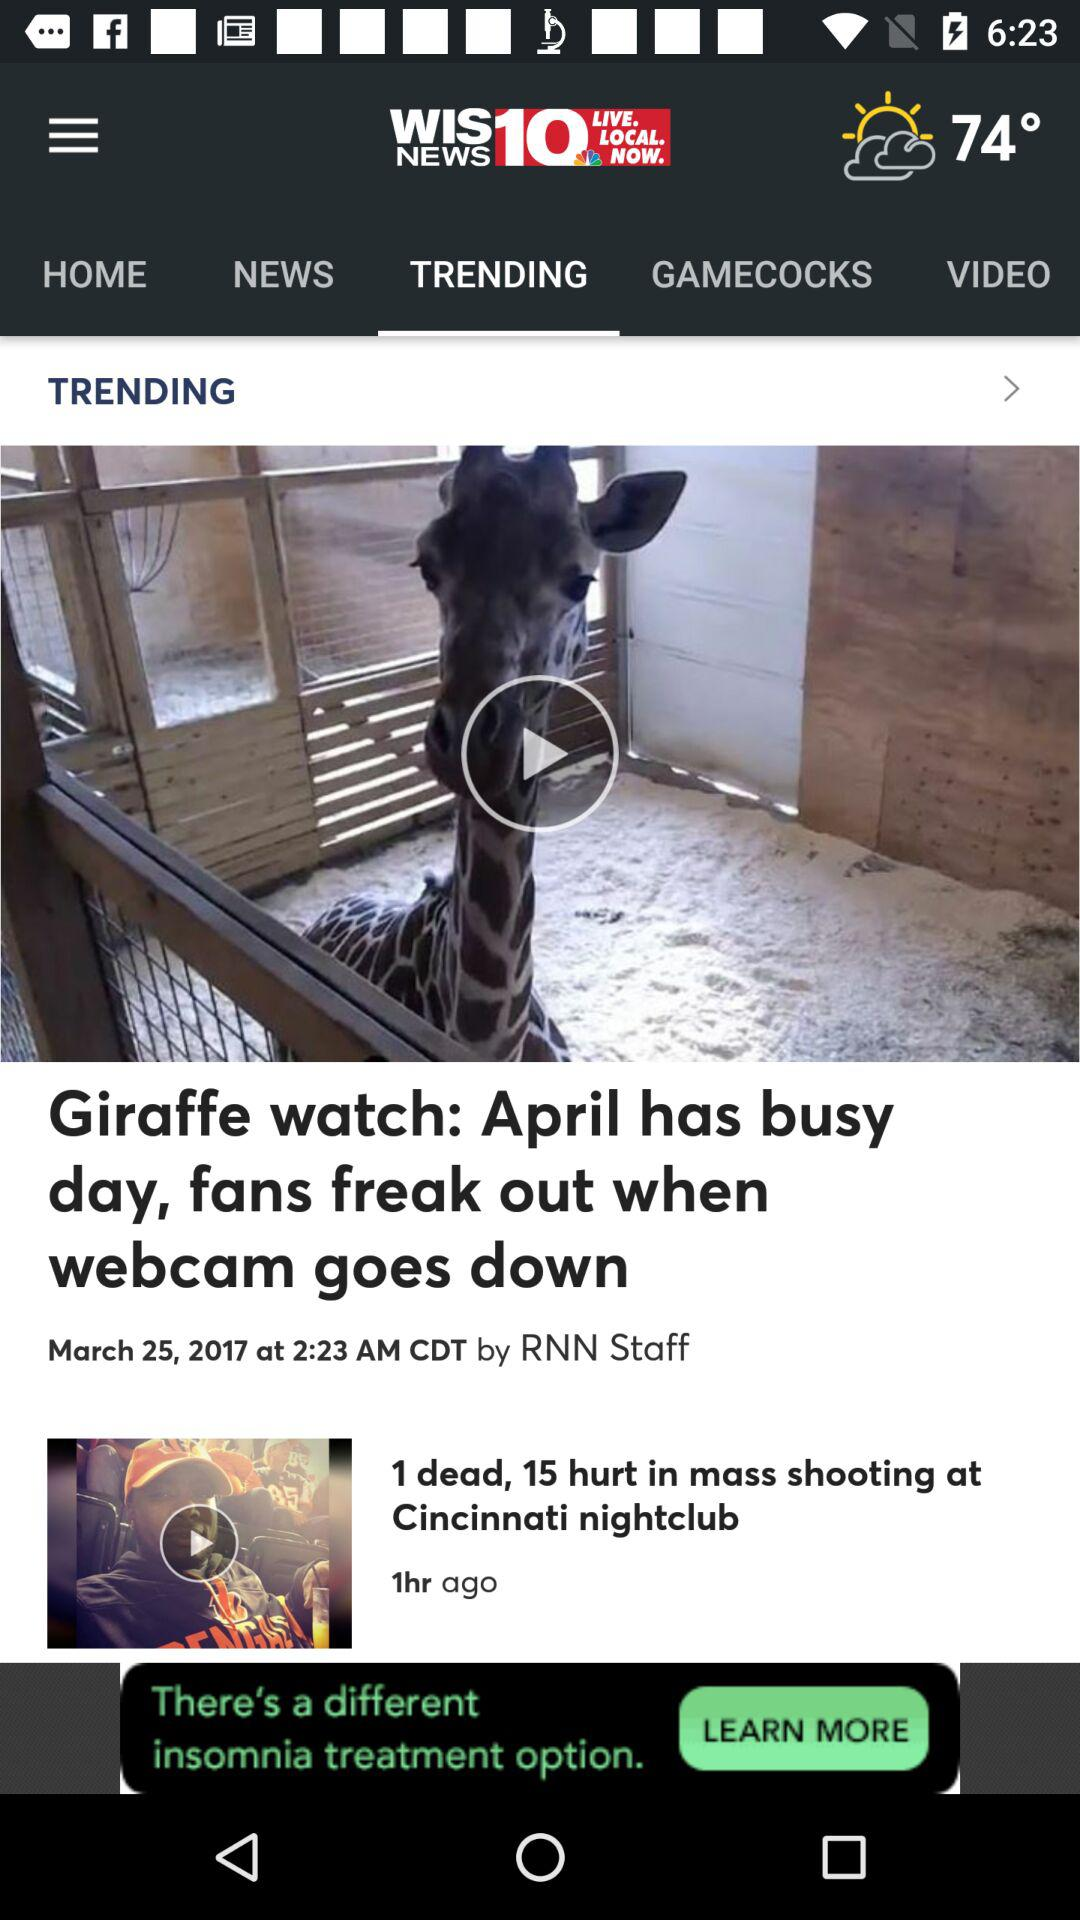What is the temperature? The temperature is 74°. 